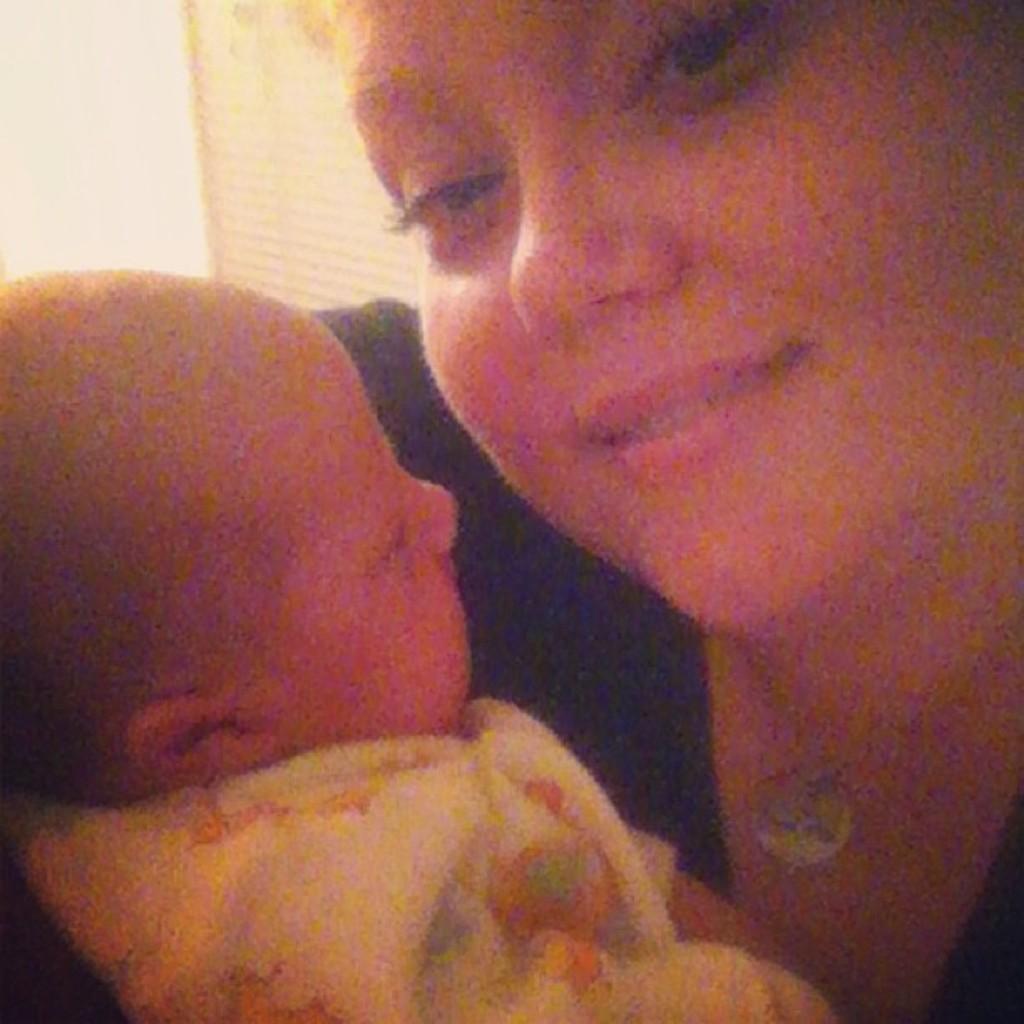Could you give a brief overview of what you see in this image? In this image there is one woman who is smiling and she is holding one baby, in the background there is a wall. 